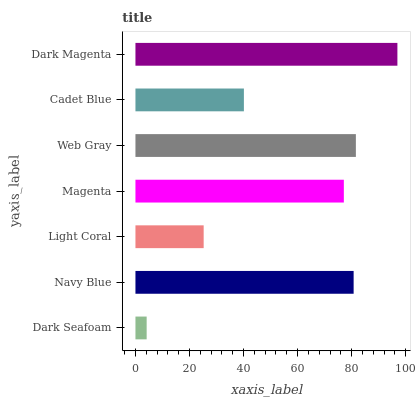Is Dark Seafoam the minimum?
Answer yes or no. Yes. Is Dark Magenta the maximum?
Answer yes or no. Yes. Is Navy Blue the minimum?
Answer yes or no. No. Is Navy Blue the maximum?
Answer yes or no. No. Is Navy Blue greater than Dark Seafoam?
Answer yes or no. Yes. Is Dark Seafoam less than Navy Blue?
Answer yes or no. Yes. Is Dark Seafoam greater than Navy Blue?
Answer yes or no. No. Is Navy Blue less than Dark Seafoam?
Answer yes or no. No. Is Magenta the high median?
Answer yes or no. Yes. Is Magenta the low median?
Answer yes or no. Yes. Is Navy Blue the high median?
Answer yes or no. No. Is Navy Blue the low median?
Answer yes or no. No. 